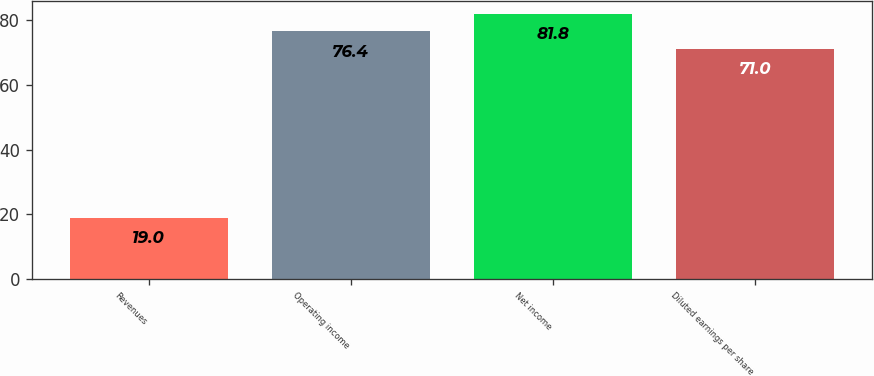Convert chart to OTSL. <chart><loc_0><loc_0><loc_500><loc_500><bar_chart><fcel>Revenues<fcel>Operating income<fcel>Net income<fcel>Diluted earnings per share<nl><fcel>19<fcel>76.4<fcel>81.8<fcel>71<nl></chart> 